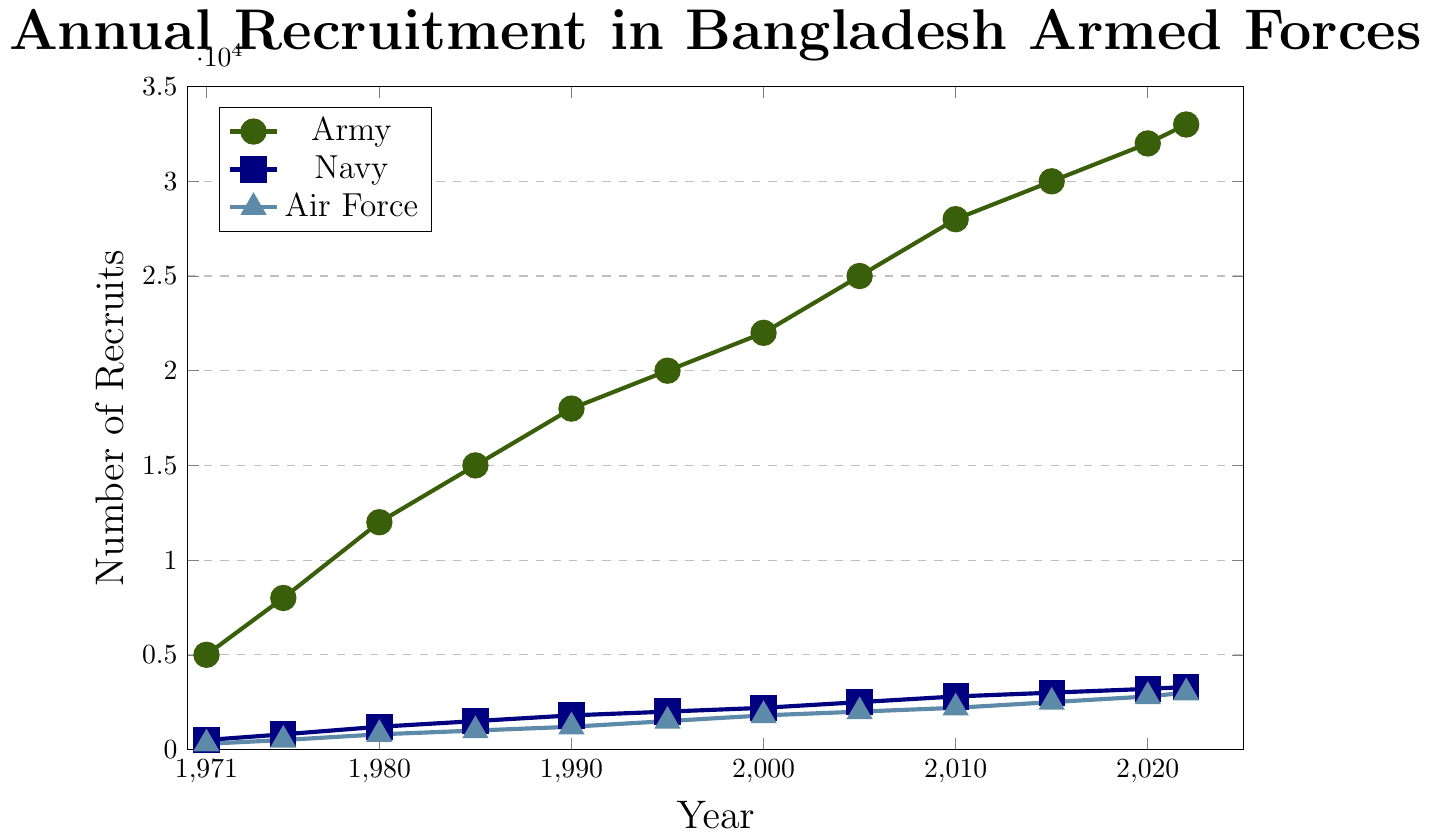What was the recruitment number for the Army in 1985? Look at the point corresponding to 1985 on the Army line (green). The number at that point is 15000.
Answer: 15000 Which branch had the least recruits in 1971? Compare the 1971 recruitment numbers for Army (5000), Navy (500), and Air Force (300). The Air Force has the smallest number.
Answer: Air Force How did the Navy recruitment change from 2000 to 2005? Find the Navy recruitment numbers for 2000 (2200) and 2005 (2500), then subtract the former from the latter: 2500 - 2200 = 300.
Answer: Increased by 300 What is the difference between the Army and Air Force recruitment numbers in 2022? Subtract the Air Force recruitment number (3000) from the Army's (33000) in 2022. The difference is 33000 - 3000 = 30000.
Answer: 30000 By how much did the Air Force recruitment increase between 1990 and 2020? Find the Air Force numbers for 1990 (1200) and 2020 (2800), then subtract 1200 from 2800: 2800 - 1200 = 1600.
Answer: 1600 Which branch saw the highest recruitment growth from 1971 to 2022? Compare the total increases for the Army (33000 - 5000 = 28000), Navy (3300 - 500 = 2800), and Air Force (3000 - 300 = 2700). The Army had the highest growth.
Answer: Army In what year did the Army recruitment first exceed 20000? Identify the year when the Army's recruitments exceeded 20000. The numbers show that it is 1995.
Answer: 1995 What is the average recruitment number for the Navy from 1980 to 2010? Find the Navy values from 1980 (1200), 1985 (1500), 1990 (1800), 1995 (2000), 2000 (2200), 2005 (2500), and 2010 (2800). Sum these and divide by the number of years: (1200 + 1500 + 1800 + 2000 + 2200 + 2500 + 2800) / 7 = 2000.
Answer: 2000 What visual indicators are used to differentiate between branches in the plot? Observe the plot to check color and shape markers: Army (green, circle), Navy (blue, square), Air Force (light blue, triangle).
Answer: Colors and markers Which branch had a consistent upward trend in recruitment numbers? Observe the trend lines for each branch from 1971 to 2022. All three branches (Army, Navy, Air Force) show a consistent upward trend.
Answer: All branches 